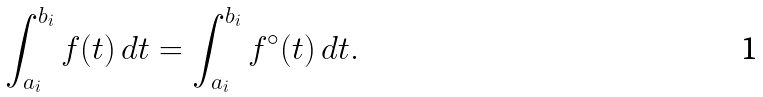Convert formula to latex. <formula><loc_0><loc_0><loc_500><loc_500>\int _ { a _ { i } } ^ { b _ { i } } f ( t ) \, d t = \int _ { a _ { i } } ^ { b _ { i } } f ^ { \circ } ( t ) \, d t .</formula> 